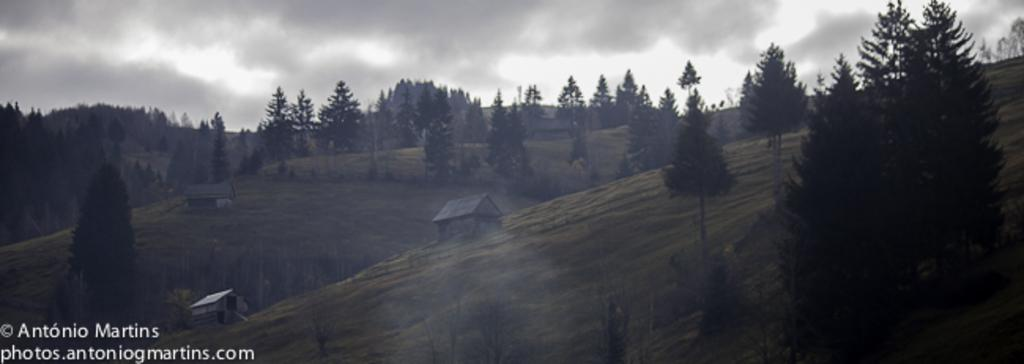What type of vegetation can be seen in the image? There are trees in the image. What type of structures are present in the image? There are small houses in the image. What is visible in the sky in the image? There are clouds in the sky in the image. Where can text be found in the image? Text is located in the left bottom corner of the image. How many owls can be seen in the image? There are no owls present in the image. What type of precipitation is falling in the image? There is no precipitation visible in the image, so it cannot be determined if it is sleet or any other type. 